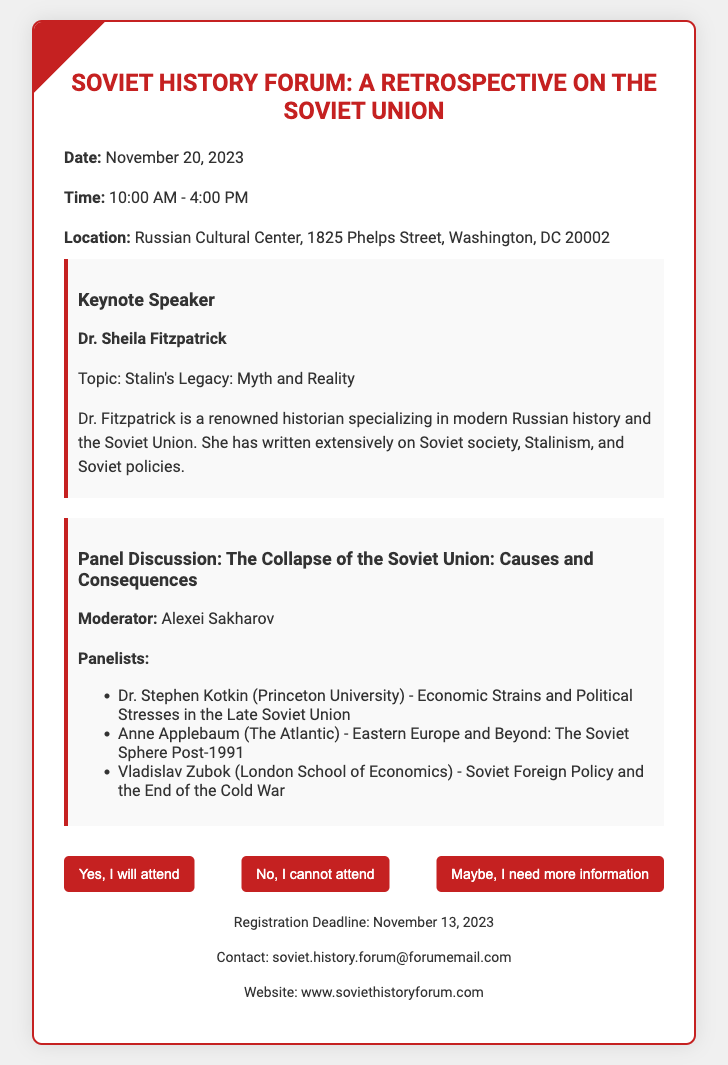What is the date of the event? The date of the event is specifically mentioned in the document as November 20, 2023.
Answer: November 20, 2023 Who is the keynote speaker? The keynote speaker is highlighted in the document, specifically identified as Dr. Sheila Fitzpatrick.
Answer: Dr. Sheila Fitzpatrick What topic will the keynote speaker discuss? The topic of the keynote speaker's discussion is provided in the document, which states "Stalin's Legacy: Myth and Reality."
Answer: Stalin's Legacy: Myth and Reality What time does the event start? The starting time is explicitly stated in the document as 10:00 AM.
Answer: 10:00 AM What location will the event take place? The location for the event is detailed in the document: Russian Cultural Center, 1825 Phelps Street, Washington, DC 20002.
Answer: Russian Cultural Center, 1825 Phelps Street, Washington, DC 20002 Who is the moderator of the panel discussion? The document identifies the moderator of the panel discussion as Alexei Sakharov.
Answer: Alexei Sakharov What is the registration deadline? The deadline for registration is specified in the document as November 13, 2023.
Answer: November 13, 2023 How many panelists are there? The number of panelists listed in the document includes three individuals.
Answer: Three What is the overarching theme of the panel discussion? The theme of the panel discussion is outlined as "The Collapse of the Soviet Union: Causes and Consequences."
Answer: The Collapse of the Soviet Union: Causes and Consequences 